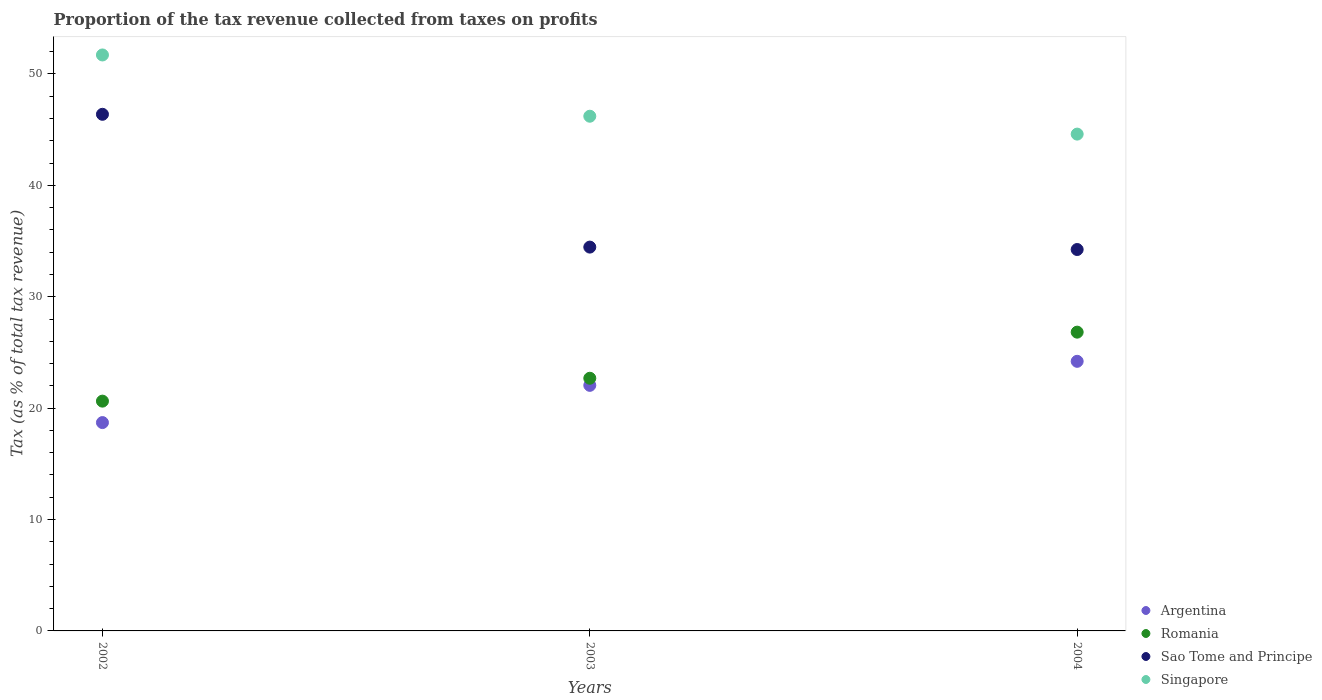Is the number of dotlines equal to the number of legend labels?
Keep it short and to the point. Yes. What is the proportion of the tax revenue collected in Singapore in 2003?
Make the answer very short. 46.21. Across all years, what is the maximum proportion of the tax revenue collected in Romania?
Make the answer very short. 26.82. Across all years, what is the minimum proportion of the tax revenue collected in Argentina?
Offer a very short reply. 18.7. In which year was the proportion of the tax revenue collected in Singapore maximum?
Provide a short and direct response. 2002. In which year was the proportion of the tax revenue collected in Argentina minimum?
Offer a terse response. 2002. What is the total proportion of the tax revenue collected in Sao Tome and Principe in the graph?
Offer a very short reply. 115.07. What is the difference between the proportion of the tax revenue collected in Argentina in 2003 and that in 2004?
Make the answer very short. -2.16. What is the difference between the proportion of the tax revenue collected in Singapore in 2004 and the proportion of the tax revenue collected in Sao Tome and Principe in 2003?
Your response must be concise. 10.14. What is the average proportion of the tax revenue collected in Romania per year?
Provide a succinct answer. 23.38. In the year 2002, what is the difference between the proportion of the tax revenue collected in Singapore and proportion of the tax revenue collected in Romania?
Your response must be concise. 31.08. What is the ratio of the proportion of the tax revenue collected in Sao Tome and Principe in 2003 to that in 2004?
Provide a succinct answer. 1.01. Is the proportion of the tax revenue collected in Romania in 2002 less than that in 2003?
Your answer should be compact. Yes. Is the difference between the proportion of the tax revenue collected in Singapore in 2003 and 2004 greater than the difference between the proportion of the tax revenue collected in Romania in 2003 and 2004?
Make the answer very short. Yes. What is the difference between the highest and the second highest proportion of the tax revenue collected in Singapore?
Offer a very short reply. 5.5. What is the difference between the highest and the lowest proportion of the tax revenue collected in Sao Tome and Principe?
Your answer should be compact. 12.14. Is it the case that in every year, the sum of the proportion of the tax revenue collected in Romania and proportion of the tax revenue collected in Argentina  is greater than the sum of proportion of the tax revenue collected in Singapore and proportion of the tax revenue collected in Sao Tome and Principe?
Your answer should be compact. No. Is it the case that in every year, the sum of the proportion of the tax revenue collected in Sao Tome and Principe and proportion of the tax revenue collected in Romania  is greater than the proportion of the tax revenue collected in Singapore?
Your answer should be compact. Yes. Is the proportion of the tax revenue collected in Romania strictly less than the proportion of the tax revenue collected in Singapore over the years?
Ensure brevity in your answer.  Yes. How many years are there in the graph?
Ensure brevity in your answer.  3. What is the difference between two consecutive major ticks on the Y-axis?
Provide a short and direct response. 10. Where does the legend appear in the graph?
Your answer should be compact. Bottom right. How are the legend labels stacked?
Your answer should be compact. Vertical. What is the title of the graph?
Your answer should be compact. Proportion of the tax revenue collected from taxes on profits. Does "Afghanistan" appear as one of the legend labels in the graph?
Ensure brevity in your answer.  No. What is the label or title of the Y-axis?
Offer a very short reply. Tax (as % of total tax revenue). What is the Tax (as % of total tax revenue) of Argentina in 2002?
Your answer should be compact. 18.7. What is the Tax (as % of total tax revenue) in Romania in 2002?
Offer a very short reply. 20.63. What is the Tax (as % of total tax revenue) in Sao Tome and Principe in 2002?
Your answer should be very brief. 46.38. What is the Tax (as % of total tax revenue) of Singapore in 2002?
Give a very brief answer. 51.71. What is the Tax (as % of total tax revenue) of Argentina in 2003?
Offer a very short reply. 22.05. What is the Tax (as % of total tax revenue) in Romania in 2003?
Give a very brief answer. 22.68. What is the Tax (as % of total tax revenue) of Sao Tome and Principe in 2003?
Make the answer very short. 34.46. What is the Tax (as % of total tax revenue) of Singapore in 2003?
Give a very brief answer. 46.21. What is the Tax (as % of total tax revenue) of Argentina in 2004?
Offer a terse response. 24.2. What is the Tax (as % of total tax revenue) of Romania in 2004?
Offer a very short reply. 26.82. What is the Tax (as % of total tax revenue) in Sao Tome and Principe in 2004?
Your answer should be very brief. 34.24. What is the Tax (as % of total tax revenue) of Singapore in 2004?
Offer a very short reply. 44.6. Across all years, what is the maximum Tax (as % of total tax revenue) of Argentina?
Your answer should be compact. 24.2. Across all years, what is the maximum Tax (as % of total tax revenue) of Romania?
Your response must be concise. 26.82. Across all years, what is the maximum Tax (as % of total tax revenue) in Sao Tome and Principe?
Your answer should be very brief. 46.38. Across all years, what is the maximum Tax (as % of total tax revenue) of Singapore?
Your answer should be very brief. 51.71. Across all years, what is the minimum Tax (as % of total tax revenue) in Argentina?
Keep it short and to the point. 18.7. Across all years, what is the minimum Tax (as % of total tax revenue) in Romania?
Provide a short and direct response. 20.63. Across all years, what is the minimum Tax (as % of total tax revenue) of Sao Tome and Principe?
Your answer should be compact. 34.24. Across all years, what is the minimum Tax (as % of total tax revenue) of Singapore?
Give a very brief answer. 44.6. What is the total Tax (as % of total tax revenue) of Argentina in the graph?
Give a very brief answer. 64.95. What is the total Tax (as % of total tax revenue) of Romania in the graph?
Give a very brief answer. 70.13. What is the total Tax (as % of total tax revenue) of Sao Tome and Principe in the graph?
Give a very brief answer. 115.07. What is the total Tax (as % of total tax revenue) of Singapore in the graph?
Give a very brief answer. 142.51. What is the difference between the Tax (as % of total tax revenue) in Argentina in 2002 and that in 2003?
Ensure brevity in your answer.  -3.34. What is the difference between the Tax (as % of total tax revenue) in Romania in 2002 and that in 2003?
Your answer should be compact. -2.05. What is the difference between the Tax (as % of total tax revenue) of Sao Tome and Principe in 2002 and that in 2003?
Give a very brief answer. 11.92. What is the difference between the Tax (as % of total tax revenue) in Argentina in 2002 and that in 2004?
Make the answer very short. -5.5. What is the difference between the Tax (as % of total tax revenue) in Romania in 2002 and that in 2004?
Keep it short and to the point. -6.19. What is the difference between the Tax (as % of total tax revenue) in Sao Tome and Principe in 2002 and that in 2004?
Ensure brevity in your answer.  12.14. What is the difference between the Tax (as % of total tax revenue) of Singapore in 2002 and that in 2004?
Keep it short and to the point. 7.11. What is the difference between the Tax (as % of total tax revenue) of Argentina in 2003 and that in 2004?
Provide a succinct answer. -2.16. What is the difference between the Tax (as % of total tax revenue) in Romania in 2003 and that in 2004?
Make the answer very short. -4.14. What is the difference between the Tax (as % of total tax revenue) of Sao Tome and Principe in 2003 and that in 2004?
Offer a terse response. 0.22. What is the difference between the Tax (as % of total tax revenue) of Singapore in 2003 and that in 2004?
Your answer should be compact. 1.61. What is the difference between the Tax (as % of total tax revenue) of Argentina in 2002 and the Tax (as % of total tax revenue) of Romania in 2003?
Ensure brevity in your answer.  -3.98. What is the difference between the Tax (as % of total tax revenue) in Argentina in 2002 and the Tax (as % of total tax revenue) in Sao Tome and Principe in 2003?
Give a very brief answer. -15.75. What is the difference between the Tax (as % of total tax revenue) in Argentina in 2002 and the Tax (as % of total tax revenue) in Singapore in 2003?
Your response must be concise. -27.5. What is the difference between the Tax (as % of total tax revenue) of Romania in 2002 and the Tax (as % of total tax revenue) of Sao Tome and Principe in 2003?
Ensure brevity in your answer.  -13.83. What is the difference between the Tax (as % of total tax revenue) of Romania in 2002 and the Tax (as % of total tax revenue) of Singapore in 2003?
Offer a terse response. -25.58. What is the difference between the Tax (as % of total tax revenue) in Sao Tome and Principe in 2002 and the Tax (as % of total tax revenue) in Singapore in 2003?
Provide a succinct answer. 0.17. What is the difference between the Tax (as % of total tax revenue) in Argentina in 2002 and the Tax (as % of total tax revenue) in Romania in 2004?
Offer a terse response. -8.12. What is the difference between the Tax (as % of total tax revenue) in Argentina in 2002 and the Tax (as % of total tax revenue) in Sao Tome and Principe in 2004?
Keep it short and to the point. -15.54. What is the difference between the Tax (as % of total tax revenue) in Argentina in 2002 and the Tax (as % of total tax revenue) in Singapore in 2004?
Offer a very short reply. -25.9. What is the difference between the Tax (as % of total tax revenue) in Romania in 2002 and the Tax (as % of total tax revenue) in Sao Tome and Principe in 2004?
Keep it short and to the point. -13.61. What is the difference between the Tax (as % of total tax revenue) in Romania in 2002 and the Tax (as % of total tax revenue) in Singapore in 2004?
Offer a terse response. -23.97. What is the difference between the Tax (as % of total tax revenue) of Sao Tome and Principe in 2002 and the Tax (as % of total tax revenue) of Singapore in 2004?
Offer a terse response. 1.78. What is the difference between the Tax (as % of total tax revenue) in Argentina in 2003 and the Tax (as % of total tax revenue) in Romania in 2004?
Provide a short and direct response. -4.78. What is the difference between the Tax (as % of total tax revenue) in Argentina in 2003 and the Tax (as % of total tax revenue) in Sao Tome and Principe in 2004?
Provide a succinct answer. -12.19. What is the difference between the Tax (as % of total tax revenue) of Argentina in 2003 and the Tax (as % of total tax revenue) of Singapore in 2004?
Your answer should be compact. -22.55. What is the difference between the Tax (as % of total tax revenue) in Romania in 2003 and the Tax (as % of total tax revenue) in Sao Tome and Principe in 2004?
Offer a very short reply. -11.56. What is the difference between the Tax (as % of total tax revenue) of Romania in 2003 and the Tax (as % of total tax revenue) of Singapore in 2004?
Give a very brief answer. -21.92. What is the difference between the Tax (as % of total tax revenue) of Sao Tome and Principe in 2003 and the Tax (as % of total tax revenue) of Singapore in 2004?
Keep it short and to the point. -10.14. What is the average Tax (as % of total tax revenue) in Argentina per year?
Keep it short and to the point. 21.65. What is the average Tax (as % of total tax revenue) in Romania per year?
Make the answer very short. 23.38. What is the average Tax (as % of total tax revenue) in Sao Tome and Principe per year?
Your response must be concise. 38.36. What is the average Tax (as % of total tax revenue) of Singapore per year?
Your answer should be very brief. 47.5. In the year 2002, what is the difference between the Tax (as % of total tax revenue) in Argentina and Tax (as % of total tax revenue) in Romania?
Your answer should be very brief. -1.92. In the year 2002, what is the difference between the Tax (as % of total tax revenue) in Argentina and Tax (as % of total tax revenue) in Sao Tome and Principe?
Offer a terse response. -27.67. In the year 2002, what is the difference between the Tax (as % of total tax revenue) in Argentina and Tax (as % of total tax revenue) in Singapore?
Offer a terse response. -33. In the year 2002, what is the difference between the Tax (as % of total tax revenue) in Romania and Tax (as % of total tax revenue) in Sao Tome and Principe?
Ensure brevity in your answer.  -25.75. In the year 2002, what is the difference between the Tax (as % of total tax revenue) in Romania and Tax (as % of total tax revenue) in Singapore?
Keep it short and to the point. -31.08. In the year 2002, what is the difference between the Tax (as % of total tax revenue) in Sao Tome and Principe and Tax (as % of total tax revenue) in Singapore?
Make the answer very short. -5.33. In the year 2003, what is the difference between the Tax (as % of total tax revenue) in Argentina and Tax (as % of total tax revenue) in Romania?
Offer a very short reply. -0.64. In the year 2003, what is the difference between the Tax (as % of total tax revenue) of Argentina and Tax (as % of total tax revenue) of Sao Tome and Principe?
Keep it short and to the point. -12.41. In the year 2003, what is the difference between the Tax (as % of total tax revenue) in Argentina and Tax (as % of total tax revenue) in Singapore?
Your answer should be very brief. -24.16. In the year 2003, what is the difference between the Tax (as % of total tax revenue) of Romania and Tax (as % of total tax revenue) of Sao Tome and Principe?
Keep it short and to the point. -11.77. In the year 2003, what is the difference between the Tax (as % of total tax revenue) of Romania and Tax (as % of total tax revenue) of Singapore?
Keep it short and to the point. -23.52. In the year 2003, what is the difference between the Tax (as % of total tax revenue) in Sao Tome and Principe and Tax (as % of total tax revenue) in Singapore?
Provide a short and direct response. -11.75. In the year 2004, what is the difference between the Tax (as % of total tax revenue) of Argentina and Tax (as % of total tax revenue) of Romania?
Make the answer very short. -2.62. In the year 2004, what is the difference between the Tax (as % of total tax revenue) in Argentina and Tax (as % of total tax revenue) in Sao Tome and Principe?
Provide a short and direct response. -10.04. In the year 2004, what is the difference between the Tax (as % of total tax revenue) of Argentina and Tax (as % of total tax revenue) of Singapore?
Your answer should be compact. -20.4. In the year 2004, what is the difference between the Tax (as % of total tax revenue) in Romania and Tax (as % of total tax revenue) in Sao Tome and Principe?
Provide a succinct answer. -7.42. In the year 2004, what is the difference between the Tax (as % of total tax revenue) of Romania and Tax (as % of total tax revenue) of Singapore?
Ensure brevity in your answer.  -17.78. In the year 2004, what is the difference between the Tax (as % of total tax revenue) in Sao Tome and Principe and Tax (as % of total tax revenue) in Singapore?
Your answer should be compact. -10.36. What is the ratio of the Tax (as % of total tax revenue) in Argentina in 2002 to that in 2003?
Offer a terse response. 0.85. What is the ratio of the Tax (as % of total tax revenue) in Romania in 2002 to that in 2003?
Your answer should be compact. 0.91. What is the ratio of the Tax (as % of total tax revenue) of Sao Tome and Principe in 2002 to that in 2003?
Provide a succinct answer. 1.35. What is the ratio of the Tax (as % of total tax revenue) of Singapore in 2002 to that in 2003?
Keep it short and to the point. 1.12. What is the ratio of the Tax (as % of total tax revenue) in Argentina in 2002 to that in 2004?
Provide a succinct answer. 0.77. What is the ratio of the Tax (as % of total tax revenue) in Romania in 2002 to that in 2004?
Offer a very short reply. 0.77. What is the ratio of the Tax (as % of total tax revenue) in Sao Tome and Principe in 2002 to that in 2004?
Your response must be concise. 1.35. What is the ratio of the Tax (as % of total tax revenue) of Singapore in 2002 to that in 2004?
Make the answer very short. 1.16. What is the ratio of the Tax (as % of total tax revenue) in Argentina in 2003 to that in 2004?
Ensure brevity in your answer.  0.91. What is the ratio of the Tax (as % of total tax revenue) of Romania in 2003 to that in 2004?
Make the answer very short. 0.85. What is the ratio of the Tax (as % of total tax revenue) of Singapore in 2003 to that in 2004?
Provide a short and direct response. 1.04. What is the difference between the highest and the second highest Tax (as % of total tax revenue) of Argentina?
Offer a terse response. 2.16. What is the difference between the highest and the second highest Tax (as % of total tax revenue) of Romania?
Ensure brevity in your answer.  4.14. What is the difference between the highest and the second highest Tax (as % of total tax revenue) of Sao Tome and Principe?
Offer a very short reply. 11.92. What is the difference between the highest and the lowest Tax (as % of total tax revenue) in Argentina?
Keep it short and to the point. 5.5. What is the difference between the highest and the lowest Tax (as % of total tax revenue) in Romania?
Provide a short and direct response. 6.19. What is the difference between the highest and the lowest Tax (as % of total tax revenue) in Sao Tome and Principe?
Your answer should be compact. 12.14. What is the difference between the highest and the lowest Tax (as % of total tax revenue) in Singapore?
Provide a succinct answer. 7.11. 